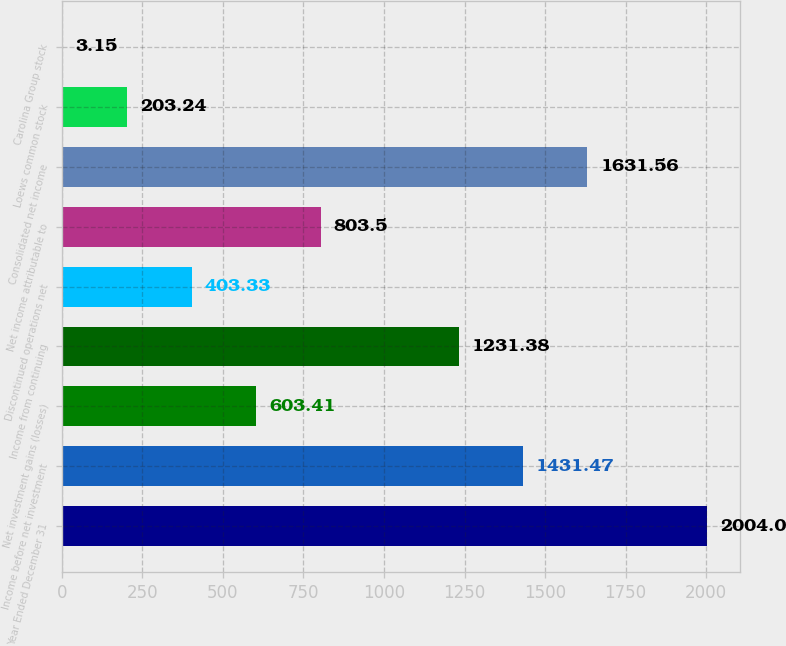Convert chart. <chart><loc_0><loc_0><loc_500><loc_500><bar_chart><fcel>Year Ended December 31<fcel>Income before net investment<fcel>Net investment gains (losses)<fcel>Income from continuing<fcel>Discontinued operations net<fcel>Net income attributable to<fcel>Consolidated net income<fcel>Loews common stock<fcel>Carolina Group stock<nl><fcel>2004<fcel>1431.47<fcel>603.41<fcel>1231.38<fcel>403.33<fcel>803.5<fcel>1631.56<fcel>203.24<fcel>3.15<nl></chart> 